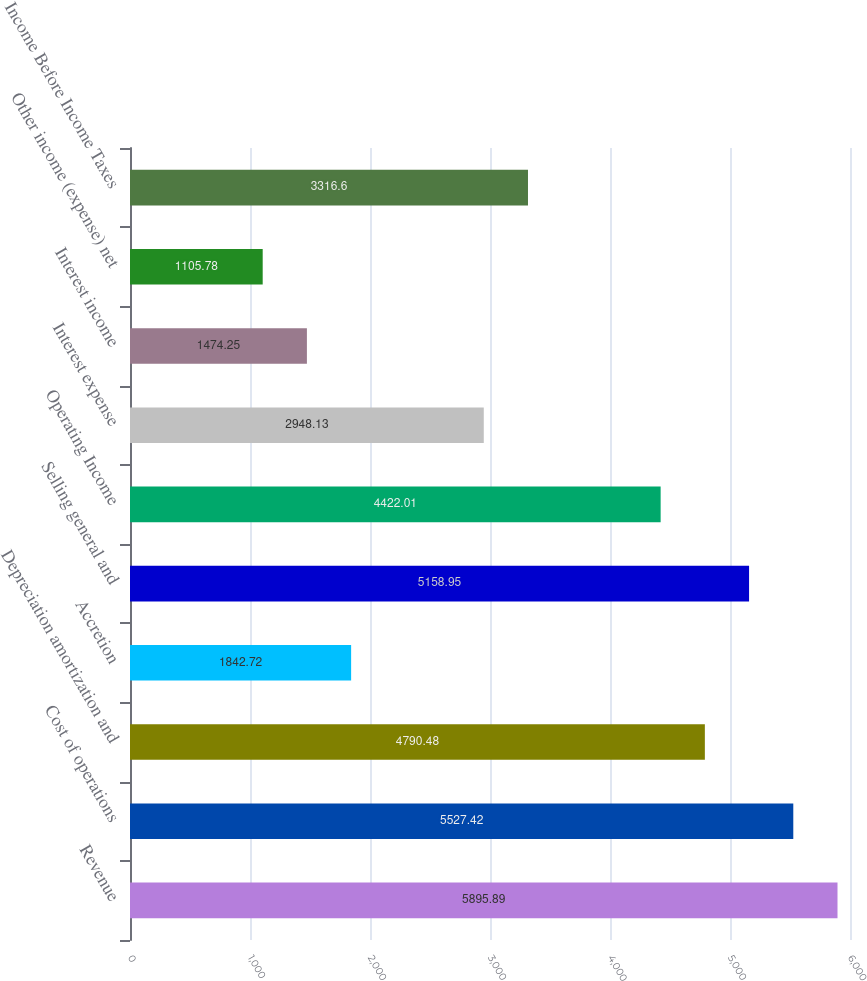<chart> <loc_0><loc_0><loc_500><loc_500><bar_chart><fcel>Revenue<fcel>Cost of operations<fcel>Depreciation amortization and<fcel>Accretion<fcel>Selling general and<fcel>Operating Income<fcel>Interest expense<fcel>Interest income<fcel>Other income (expense) net<fcel>Income Before Income Taxes<nl><fcel>5895.89<fcel>5527.42<fcel>4790.48<fcel>1842.72<fcel>5158.95<fcel>4422.01<fcel>2948.13<fcel>1474.25<fcel>1105.78<fcel>3316.6<nl></chart> 